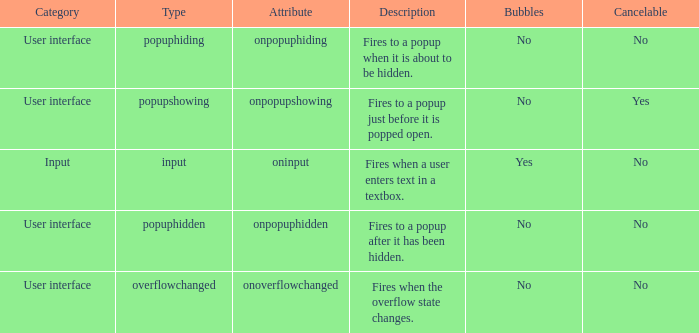What's the cancelable with bubbles being yes No. 